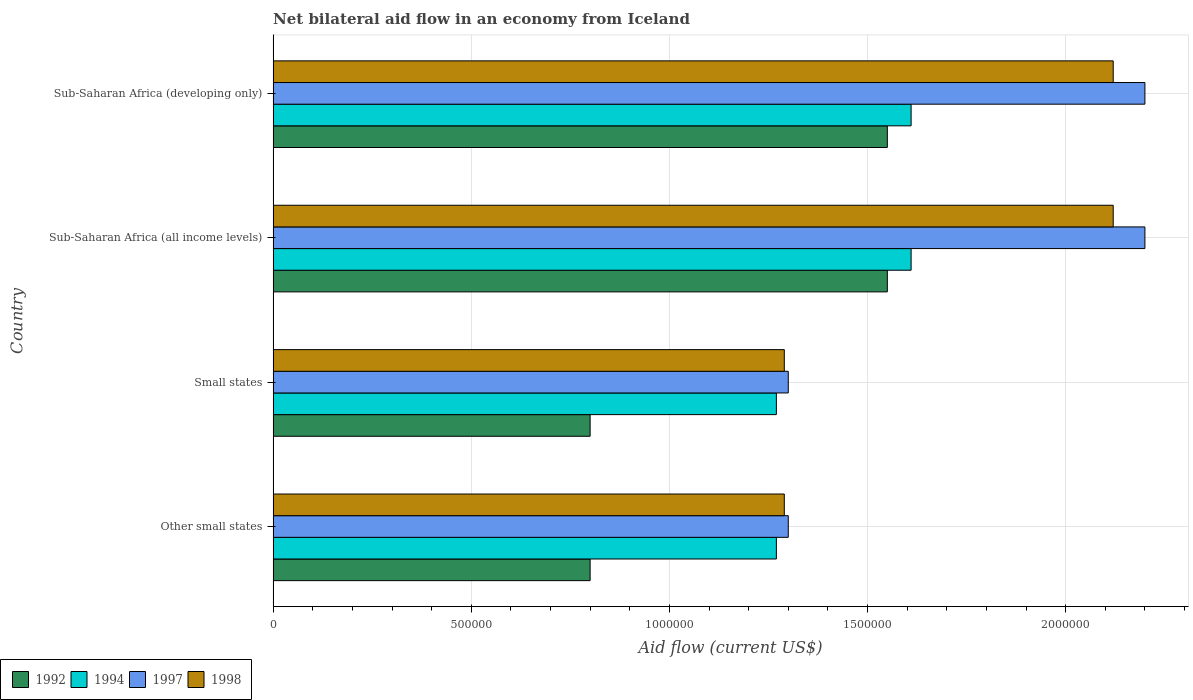How many different coloured bars are there?
Your response must be concise. 4. How many groups of bars are there?
Ensure brevity in your answer.  4. Are the number of bars on each tick of the Y-axis equal?
Your response must be concise. Yes. How many bars are there on the 3rd tick from the top?
Provide a succinct answer. 4. How many bars are there on the 3rd tick from the bottom?
Your answer should be very brief. 4. What is the label of the 2nd group of bars from the top?
Ensure brevity in your answer.  Sub-Saharan Africa (all income levels). What is the net bilateral aid flow in 1992 in Other small states?
Offer a terse response. 8.00e+05. Across all countries, what is the maximum net bilateral aid flow in 1994?
Offer a very short reply. 1.61e+06. Across all countries, what is the minimum net bilateral aid flow in 1998?
Your answer should be compact. 1.29e+06. In which country was the net bilateral aid flow in 1997 maximum?
Offer a terse response. Sub-Saharan Africa (all income levels). In which country was the net bilateral aid flow in 1997 minimum?
Make the answer very short. Other small states. What is the difference between the net bilateral aid flow in 1994 in Small states and that in Sub-Saharan Africa (developing only)?
Your answer should be very brief. -3.40e+05. What is the average net bilateral aid flow in 1998 per country?
Ensure brevity in your answer.  1.70e+06. What is the difference between the net bilateral aid flow in 1992 and net bilateral aid flow in 1998 in Sub-Saharan Africa (developing only)?
Keep it short and to the point. -5.70e+05. What is the ratio of the net bilateral aid flow in 1992 in Other small states to that in Sub-Saharan Africa (all income levels)?
Offer a terse response. 0.52. What is the difference between the highest and the second highest net bilateral aid flow in 1997?
Ensure brevity in your answer.  0. What is the difference between the highest and the lowest net bilateral aid flow in 1992?
Make the answer very short. 7.50e+05. Is the sum of the net bilateral aid flow in 1992 in Other small states and Small states greater than the maximum net bilateral aid flow in 1998 across all countries?
Offer a very short reply. No. What does the 3rd bar from the top in Sub-Saharan Africa (developing only) represents?
Provide a succinct answer. 1994. How many bars are there?
Your answer should be very brief. 16. Are all the bars in the graph horizontal?
Make the answer very short. Yes. What is the difference between two consecutive major ticks on the X-axis?
Your answer should be compact. 5.00e+05. Are the values on the major ticks of X-axis written in scientific E-notation?
Provide a succinct answer. No. How many legend labels are there?
Provide a succinct answer. 4. How are the legend labels stacked?
Keep it short and to the point. Horizontal. What is the title of the graph?
Provide a succinct answer. Net bilateral aid flow in an economy from Iceland. What is the label or title of the Y-axis?
Provide a succinct answer. Country. What is the Aid flow (current US$) of 1994 in Other small states?
Offer a very short reply. 1.27e+06. What is the Aid flow (current US$) of 1997 in Other small states?
Make the answer very short. 1.30e+06. What is the Aid flow (current US$) in 1998 in Other small states?
Your response must be concise. 1.29e+06. What is the Aid flow (current US$) of 1992 in Small states?
Provide a succinct answer. 8.00e+05. What is the Aid flow (current US$) of 1994 in Small states?
Your answer should be compact. 1.27e+06. What is the Aid flow (current US$) in 1997 in Small states?
Give a very brief answer. 1.30e+06. What is the Aid flow (current US$) of 1998 in Small states?
Offer a terse response. 1.29e+06. What is the Aid flow (current US$) of 1992 in Sub-Saharan Africa (all income levels)?
Your answer should be compact. 1.55e+06. What is the Aid flow (current US$) in 1994 in Sub-Saharan Africa (all income levels)?
Your answer should be very brief. 1.61e+06. What is the Aid flow (current US$) in 1997 in Sub-Saharan Africa (all income levels)?
Keep it short and to the point. 2.20e+06. What is the Aid flow (current US$) of 1998 in Sub-Saharan Africa (all income levels)?
Provide a short and direct response. 2.12e+06. What is the Aid flow (current US$) of 1992 in Sub-Saharan Africa (developing only)?
Provide a succinct answer. 1.55e+06. What is the Aid flow (current US$) in 1994 in Sub-Saharan Africa (developing only)?
Offer a very short reply. 1.61e+06. What is the Aid flow (current US$) in 1997 in Sub-Saharan Africa (developing only)?
Provide a succinct answer. 2.20e+06. What is the Aid flow (current US$) in 1998 in Sub-Saharan Africa (developing only)?
Provide a short and direct response. 2.12e+06. Across all countries, what is the maximum Aid flow (current US$) of 1992?
Ensure brevity in your answer.  1.55e+06. Across all countries, what is the maximum Aid flow (current US$) in 1994?
Ensure brevity in your answer.  1.61e+06. Across all countries, what is the maximum Aid flow (current US$) in 1997?
Your response must be concise. 2.20e+06. Across all countries, what is the maximum Aid flow (current US$) in 1998?
Provide a succinct answer. 2.12e+06. Across all countries, what is the minimum Aid flow (current US$) in 1994?
Offer a terse response. 1.27e+06. Across all countries, what is the minimum Aid flow (current US$) in 1997?
Provide a succinct answer. 1.30e+06. Across all countries, what is the minimum Aid flow (current US$) in 1998?
Provide a succinct answer. 1.29e+06. What is the total Aid flow (current US$) of 1992 in the graph?
Make the answer very short. 4.70e+06. What is the total Aid flow (current US$) in 1994 in the graph?
Provide a short and direct response. 5.76e+06. What is the total Aid flow (current US$) of 1998 in the graph?
Make the answer very short. 6.82e+06. What is the difference between the Aid flow (current US$) in 1992 in Other small states and that in Small states?
Your answer should be very brief. 0. What is the difference between the Aid flow (current US$) in 1998 in Other small states and that in Small states?
Offer a terse response. 0. What is the difference between the Aid flow (current US$) of 1992 in Other small states and that in Sub-Saharan Africa (all income levels)?
Make the answer very short. -7.50e+05. What is the difference between the Aid flow (current US$) of 1994 in Other small states and that in Sub-Saharan Africa (all income levels)?
Offer a terse response. -3.40e+05. What is the difference between the Aid flow (current US$) in 1997 in Other small states and that in Sub-Saharan Africa (all income levels)?
Give a very brief answer. -9.00e+05. What is the difference between the Aid flow (current US$) of 1998 in Other small states and that in Sub-Saharan Africa (all income levels)?
Provide a succinct answer. -8.30e+05. What is the difference between the Aid flow (current US$) in 1992 in Other small states and that in Sub-Saharan Africa (developing only)?
Give a very brief answer. -7.50e+05. What is the difference between the Aid flow (current US$) in 1994 in Other small states and that in Sub-Saharan Africa (developing only)?
Make the answer very short. -3.40e+05. What is the difference between the Aid flow (current US$) in 1997 in Other small states and that in Sub-Saharan Africa (developing only)?
Your response must be concise. -9.00e+05. What is the difference between the Aid flow (current US$) of 1998 in Other small states and that in Sub-Saharan Africa (developing only)?
Make the answer very short. -8.30e+05. What is the difference between the Aid flow (current US$) of 1992 in Small states and that in Sub-Saharan Africa (all income levels)?
Your response must be concise. -7.50e+05. What is the difference between the Aid flow (current US$) in 1997 in Small states and that in Sub-Saharan Africa (all income levels)?
Your response must be concise. -9.00e+05. What is the difference between the Aid flow (current US$) of 1998 in Small states and that in Sub-Saharan Africa (all income levels)?
Make the answer very short. -8.30e+05. What is the difference between the Aid flow (current US$) of 1992 in Small states and that in Sub-Saharan Africa (developing only)?
Ensure brevity in your answer.  -7.50e+05. What is the difference between the Aid flow (current US$) of 1994 in Small states and that in Sub-Saharan Africa (developing only)?
Provide a short and direct response. -3.40e+05. What is the difference between the Aid flow (current US$) in 1997 in Small states and that in Sub-Saharan Africa (developing only)?
Your answer should be compact. -9.00e+05. What is the difference between the Aid flow (current US$) of 1998 in Small states and that in Sub-Saharan Africa (developing only)?
Keep it short and to the point. -8.30e+05. What is the difference between the Aid flow (current US$) in 1997 in Sub-Saharan Africa (all income levels) and that in Sub-Saharan Africa (developing only)?
Give a very brief answer. 0. What is the difference between the Aid flow (current US$) of 1992 in Other small states and the Aid flow (current US$) of 1994 in Small states?
Make the answer very short. -4.70e+05. What is the difference between the Aid flow (current US$) of 1992 in Other small states and the Aid flow (current US$) of 1997 in Small states?
Provide a short and direct response. -5.00e+05. What is the difference between the Aid flow (current US$) of 1992 in Other small states and the Aid flow (current US$) of 1998 in Small states?
Provide a short and direct response. -4.90e+05. What is the difference between the Aid flow (current US$) in 1992 in Other small states and the Aid flow (current US$) in 1994 in Sub-Saharan Africa (all income levels)?
Your response must be concise. -8.10e+05. What is the difference between the Aid flow (current US$) in 1992 in Other small states and the Aid flow (current US$) in 1997 in Sub-Saharan Africa (all income levels)?
Your answer should be very brief. -1.40e+06. What is the difference between the Aid flow (current US$) in 1992 in Other small states and the Aid flow (current US$) in 1998 in Sub-Saharan Africa (all income levels)?
Offer a very short reply. -1.32e+06. What is the difference between the Aid flow (current US$) in 1994 in Other small states and the Aid flow (current US$) in 1997 in Sub-Saharan Africa (all income levels)?
Offer a terse response. -9.30e+05. What is the difference between the Aid flow (current US$) in 1994 in Other small states and the Aid flow (current US$) in 1998 in Sub-Saharan Africa (all income levels)?
Your answer should be very brief. -8.50e+05. What is the difference between the Aid flow (current US$) in 1997 in Other small states and the Aid flow (current US$) in 1998 in Sub-Saharan Africa (all income levels)?
Make the answer very short. -8.20e+05. What is the difference between the Aid flow (current US$) in 1992 in Other small states and the Aid flow (current US$) in 1994 in Sub-Saharan Africa (developing only)?
Keep it short and to the point. -8.10e+05. What is the difference between the Aid flow (current US$) in 1992 in Other small states and the Aid flow (current US$) in 1997 in Sub-Saharan Africa (developing only)?
Your response must be concise. -1.40e+06. What is the difference between the Aid flow (current US$) in 1992 in Other small states and the Aid flow (current US$) in 1998 in Sub-Saharan Africa (developing only)?
Keep it short and to the point. -1.32e+06. What is the difference between the Aid flow (current US$) in 1994 in Other small states and the Aid flow (current US$) in 1997 in Sub-Saharan Africa (developing only)?
Give a very brief answer. -9.30e+05. What is the difference between the Aid flow (current US$) of 1994 in Other small states and the Aid flow (current US$) of 1998 in Sub-Saharan Africa (developing only)?
Your answer should be very brief. -8.50e+05. What is the difference between the Aid flow (current US$) in 1997 in Other small states and the Aid flow (current US$) in 1998 in Sub-Saharan Africa (developing only)?
Your answer should be very brief. -8.20e+05. What is the difference between the Aid flow (current US$) of 1992 in Small states and the Aid flow (current US$) of 1994 in Sub-Saharan Africa (all income levels)?
Offer a very short reply. -8.10e+05. What is the difference between the Aid flow (current US$) of 1992 in Small states and the Aid flow (current US$) of 1997 in Sub-Saharan Africa (all income levels)?
Provide a short and direct response. -1.40e+06. What is the difference between the Aid flow (current US$) in 1992 in Small states and the Aid flow (current US$) in 1998 in Sub-Saharan Africa (all income levels)?
Ensure brevity in your answer.  -1.32e+06. What is the difference between the Aid flow (current US$) in 1994 in Small states and the Aid flow (current US$) in 1997 in Sub-Saharan Africa (all income levels)?
Offer a very short reply. -9.30e+05. What is the difference between the Aid flow (current US$) in 1994 in Small states and the Aid flow (current US$) in 1998 in Sub-Saharan Africa (all income levels)?
Provide a short and direct response. -8.50e+05. What is the difference between the Aid flow (current US$) in 1997 in Small states and the Aid flow (current US$) in 1998 in Sub-Saharan Africa (all income levels)?
Make the answer very short. -8.20e+05. What is the difference between the Aid flow (current US$) of 1992 in Small states and the Aid flow (current US$) of 1994 in Sub-Saharan Africa (developing only)?
Offer a terse response. -8.10e+05. What is the difference between the Aid flow (current US$) of 1992 in Small states and the Aid flow (current US$) of 1997 in Sub-Saharan Africa (developing only)?
Make the answer very short. -1.40e+06. What is the difference between the Aid flow (current US$) of 1992 in Small states and the Aid flow (current US$) of 1998 in Sub-Saharan Africa (developing only)?
Ensure brevity in your answer.  -1.32e+06. What is the difference between the Aid flow (current US$) of 1994 in Small states and the Aid flow (current US$) of 1997 in Sub-Saharan Africa (developing only)?
Offer a very short reply. -9.30e+05. What is the difference between the Aid flow (current US$) in 1994 in Small states and the Aid flow (current US$) in 1998 in Sub-Saharan Africa (developing only)?
Your answer should be compact. -8.50e+05. What is the difference between the Aid flow (current US$) in 1997 in Small states and the Aid flow (current US$) in 1998 in Sub-Saharan Africa (developing only)?
Provide a short and direct response. -8.20e+05. What is the difference between the Aid flow (current US$) in 1992 in Sub-Saharan Africa (all income levels) and the Aid flow (current US$) in 1997 in Sub-Saharan Africa (developing only)?
Keep it short and to the point. -6.50e+05. What is the difference between the Aid flow (current US$) in 1992 in Sub-Saharan Africa (all income levels) and the Aid flow (current US$) in 1998 in Sub-Saharan Africa (developing only)?
Your answer should be very brief. -5.70e+05. What is the difference between the Aid flow (current US$) in 1994 in Sub-Saharan Africa (all income levels) and the Aid flow (current US$) in 1997 in Sub-Saharan Africa (developing only)?
Ensure brevity in your answer.  -5.90e+05. What is the difference between the Aid flow (current US$) in 1994 in Sub-Saharan Africa (all income levels) and the Aid flow (current US$) in 1998 in Sub-Saharan Africa (developing only)?
Ensure brevity in your answer.  -5.10e+05. What is the average Aid flow (current US$) in 1992 per country?
Provide a short and direct response. 1.18e+06. What is the average Aid flow (current US$) in 1994 per country?
Keep it short and to the point. 1.44e+06. What is the average Aid flow (current US$) of 1997 per country?
Your answer should be compact. 1.75e+06. What is the average Aid flow (current US$) of 1998 per country?
Ensure brevity in your answer.  1.70e+06. What is the difference between the Aid flow (current US$) in 1992 and Aid flow (current US$) in 1994 in Other small states?
Make the answer very short. -4.70e+05. What is the difference between the Aid flow (current US$) of 1992 and Aid flow (current US$) of 1997 in Other small states?
Keep it short and to the point. -5.00e+05. What is the difference between the Aid flow (current US$) in 1992 and Aid flow (current US$) in 1998 in Other small states?
Provide a short and direct response. -4.90e+05. What is the difference between the Aid flow (current US$) of 1994 and Aid flow (current US$) of 1997 in Other small states?
Your answer should be compact. -3.00e+04. What is the difference between the Aid flow (current US$) in 1992 and Aid flow (current US$) in 1994 in Small states?
Provide a short and direct response. -4.70e+05. What is the difference between the Aid flow (current US$) of 1992 and Aid flow (current US$) of 1997 in Small states?
Give a very brief answer. -5.00e+05. What is the difference between the Aid flow (current US$) in 1992 and Aid flow (current US$) in 1998 in Small states?
Offer a terse response. -4.90e+05. What is the difference between the Aid flow (current US$) in 1997 and Aid flow (current US$) in 1998 in Small states?
Give a very brief answer. 10000. What is the difference between the Aid flow (current US$) of 1992 and Aid flow (current US$) of 1994 in Sub-Saharan Africa (all income levels)?
Your response must be concise. -6.00e+04. What is the difference between the Aid flow (current US$) of 1992 and Aid flow (current US$) of 1997 in Sub-Saharan Africa (all income levels)?
Ensure brevity in your answer.  -6.50e+05. What is the difference between the Aid flow (current US$) of 1992 and Aid flow (current US$) of 1998 in Sub-Saharan Africa (all income levels)?
Give a very brief answer. -5.70e+05. What is the difference between the Aid flow (current US$) in 1994 and Aid flow (current US$) in 1997 in Sub-Saharan Africa (all income levels)?
Your answer should be compact. -5.90e+05. What is the difference between the Aid flow (current US$) of 1994 and Aid flow (current US$) of 1998 in Sub-Saharan Africa (all income levels)?
Provide a succinct answer. -5.10e+05. What is the difference between the Aid flow (current US$) of 1997 and Aid flow (current US$) of 1998 in Sub-Saharan Africa (all income levels)?
Your answer should be compact. 8.00e+04. What is the difference between the Aid flow (current US$) of 1992 and Aid flow (current US$) of 1997 in Sub-Saharan Africa (developing only)?
Make the answer very short. -6.50e+05. What is the difference between the Aid flow (current US$) of 1992 and Aid flow (current US$) of 1998 in Sub-Saharan Africa (developing only)?
Provide a succinct answer. -5.70e+05. What is the difference between the Aid flow (current US$) of 1994 and Aid flow (current US$) of 1997 in Sub-Saharan Africa (developing only)?
Provide a short and direct response. -5.90e+05. What is the difference between the Aid flow (current US$) in 1994 and Aid flow (current US$) in 1998 in Sub-Saharan Africa (developing only)?
Keep it short and to the point. -5.10e+05. What is the difference between the Aid flow (current US$) in 1997 and Aid flow (current US$) in 1998 in Sub-Saharan Africa (developing only)?
Provide a short and direct response. 8.00e+04. What is the ratio of the Aid flow (current US$) of 1992 in Other small states to that in Small states?
Your answer should be very brief. 1. What is the ratio of the Aid flow (current US$) in 1997 in Other small states to that in Small states?
Your answer should be compact. 1. What is the ratio of the Aid flow (current US$) of 1992 in Other small states to that in Sub-Saharan Africa (all income levels)?
Offer a terse response. 0.52. What is the ratio of the Aid flow (current US$) in 1994 in Other small states to that in Sub-Saharan Africa (all income levels)?
Your response must be concise. 0.79. What is the ratio of the Aid flow (current US$) in 1997 in Other small states to that in Sub-Saharan Africa (all income levels)?
Your answer should be very brief. 0.59. What is the ratio of the Aid flow (current US$) in 1998 in Other small states to that in Sub-Saharan Africa (all income levels)?
Provide a succinct answer. 0.61. What is the ratio of the Aid flow (current US$) of 1992 in Other small states to that in Sub-Saharan Africa (developing only)?
Give a very brief answer. 0.52. What is the ratio of the Aid flow (current US$) in 1994 in Other small states to that in Sub-Saharan Africa (developing only)?
Your answer should be compact. 0.79. What is the ratio of the Aid flow (current US$) in 1997 in Other small states to that in Sub-Saharan Africa (developing only)?
Offer a very short reply. 0.59. What is the ratio of the Aid flow (current US$) of 1998 in Other small states to that in Sub-Saharan Africa (developing only)?
Provide a short and direct response. 0.61. What is the ratio of the Aid flow (current US$) of 1992 in Small states to that in Sub-Saharan Africa (all income levels)?
Ensure brevity in your answer.  0.52. What is the ratio of the Aid flow (current US$) in 1994 in Small states to that in Sub-Saharan Africa (all income levels)?
Your answer should be compact. 0.79. What is the ratio of the Aid flow (current US$) in 1997 in Small states to that in Sub-Saharan Africa (all income levels)?
Offer a very short reply. 0.59. What is the ratio of the Aid flow (current US$) in 1998 in Small states to that in Sub-Saharan Africa (all income levels)?
Your answer should be very brief. 0.61. What is the ratio of the Aid flow (current US$) of 1992 in Small states to that in Sub-Saharan Africa (developing only)?
Make the answer very short. 0.52. What is the ratio of the Aid flow (current US$) in 1994 in Small states to that in Sub-Saharan Africa (developing only)?
Offer a very short reply. 0.79. What is the ratio of the Aid flow (current US$) in 1997 in Small states to that in Sub-Saharan Africa (developing only)?
Your answer should be very brief. 0.59. What is the ratio of the Aid flow (current US$) in 1998 in Small states to that in Sub-Saharan Africa (developing only)?
Give a very brief answer. 0.61. What is the ratio of the Aid flow (current US$) in 1992 in Sub-Saharan Africa (all income levels) to that in Sub-Saharan Africa (developing only)?
Offer a very short reply. 1. What is the difference between the highest and the second highest Aid flow (current US$) in 1994?
Offer a terse response. 0. What is the difference between the highest and the second highest Aid flow (current US$) of 1997?
Ensure brevity in your answer.  0. What is the difference between the highest and the second highest Aid flow (current US$) of 1998?
Make the answer very short. 0. What is the difference between the highest and the lowest Aid flow (current US$) in 1992?
Offer a terse response. 7.50e+05. What is the difference between the highest and the lowest Aid flow (current US$) in 1998?
Keep it short and to the point. 8.30e+05. 